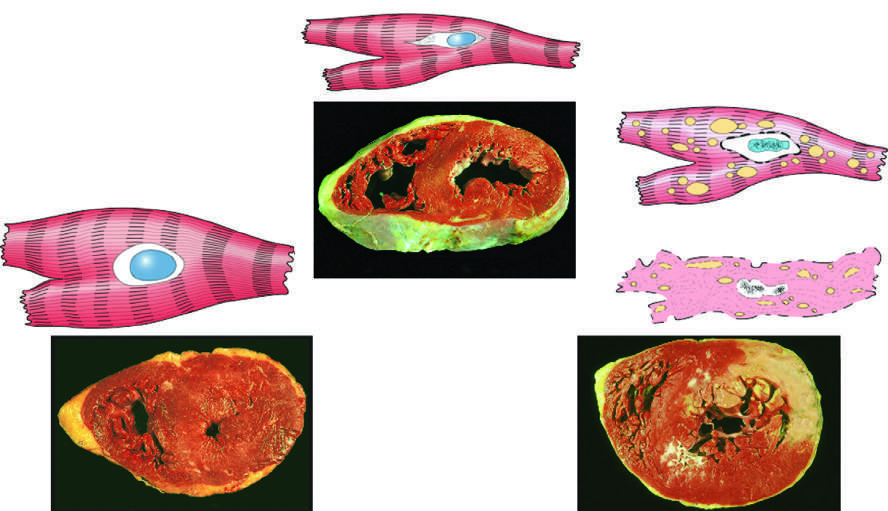s the left ventricular wall thicker than 2 cm (normal, 1-1.5 cm) in the example of myocardial hypertrophy lower left?
Answer the question using a single word or phrase. Yes 